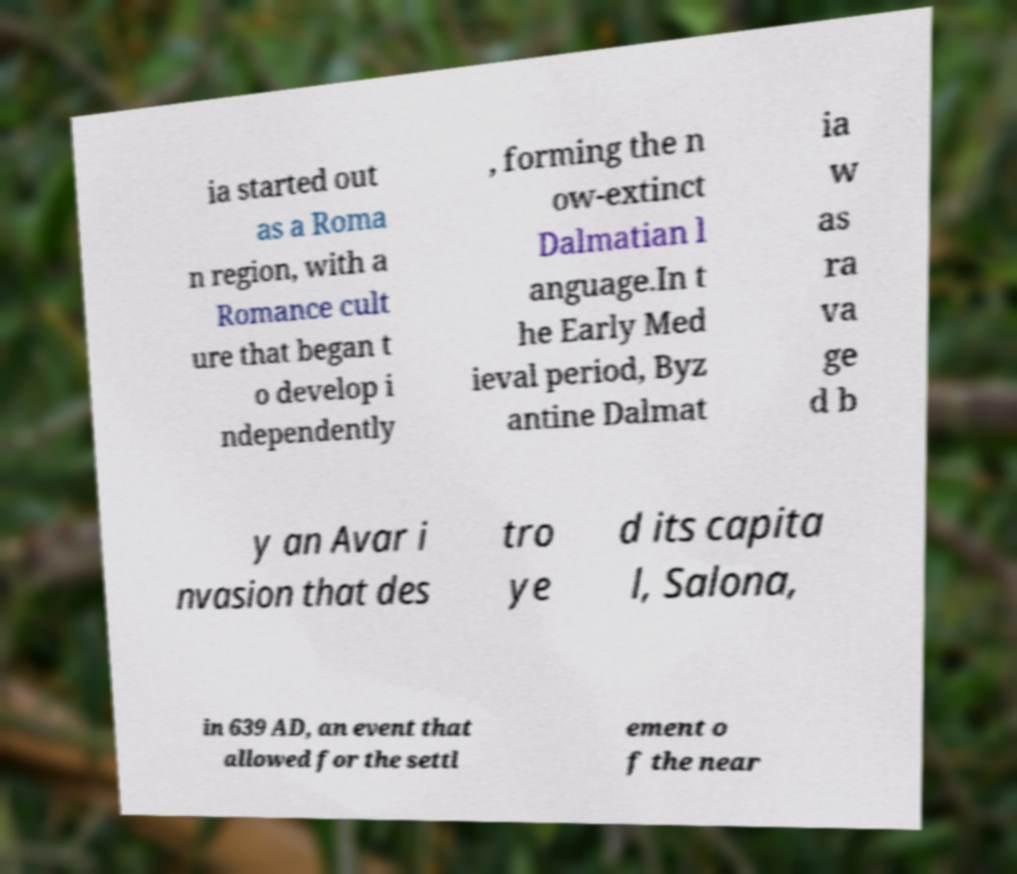There's text embedded in this image that I need extracted. Can you transcribe it verbatim? ia started out as a Roma n region, with a Romance cult ure that began t o develop i ndependently , forming the n ow-extinct Dalmatian l anguage.In t he Early Med ieval period, Byz antine Dalmat ia w as ra va ge d b y an Avar i nvasion that des tro ye d its capita l, Salona, in 639 AD, an event that allowed for the settl ement o f the near 